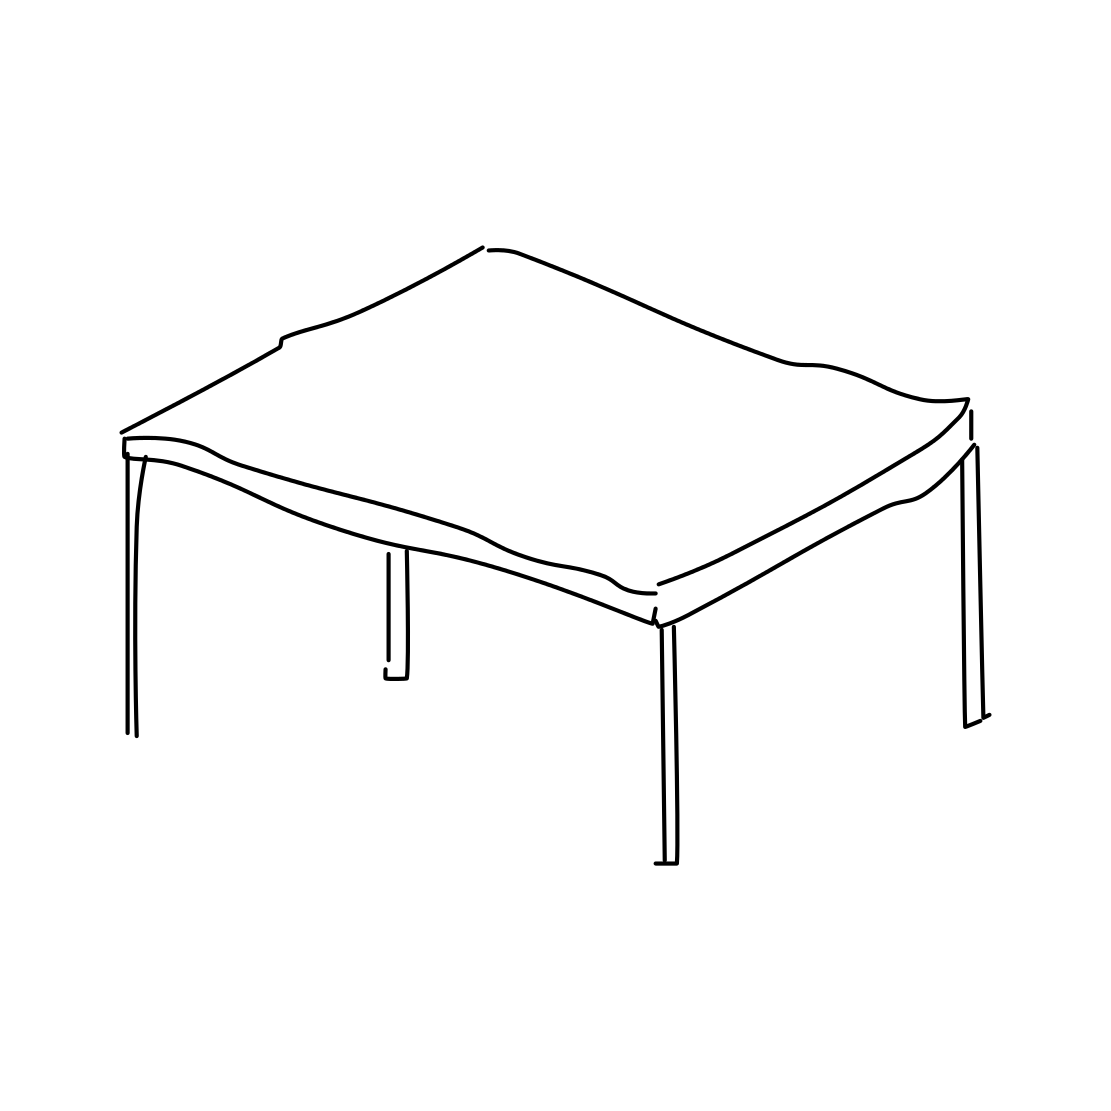In the scene, is a bell in it? After a careful examination of the image, I can confirm that there is no bell present. The image solely features a simplistic outline of a table without any additional objects or decorations, including the absence of a bell. 